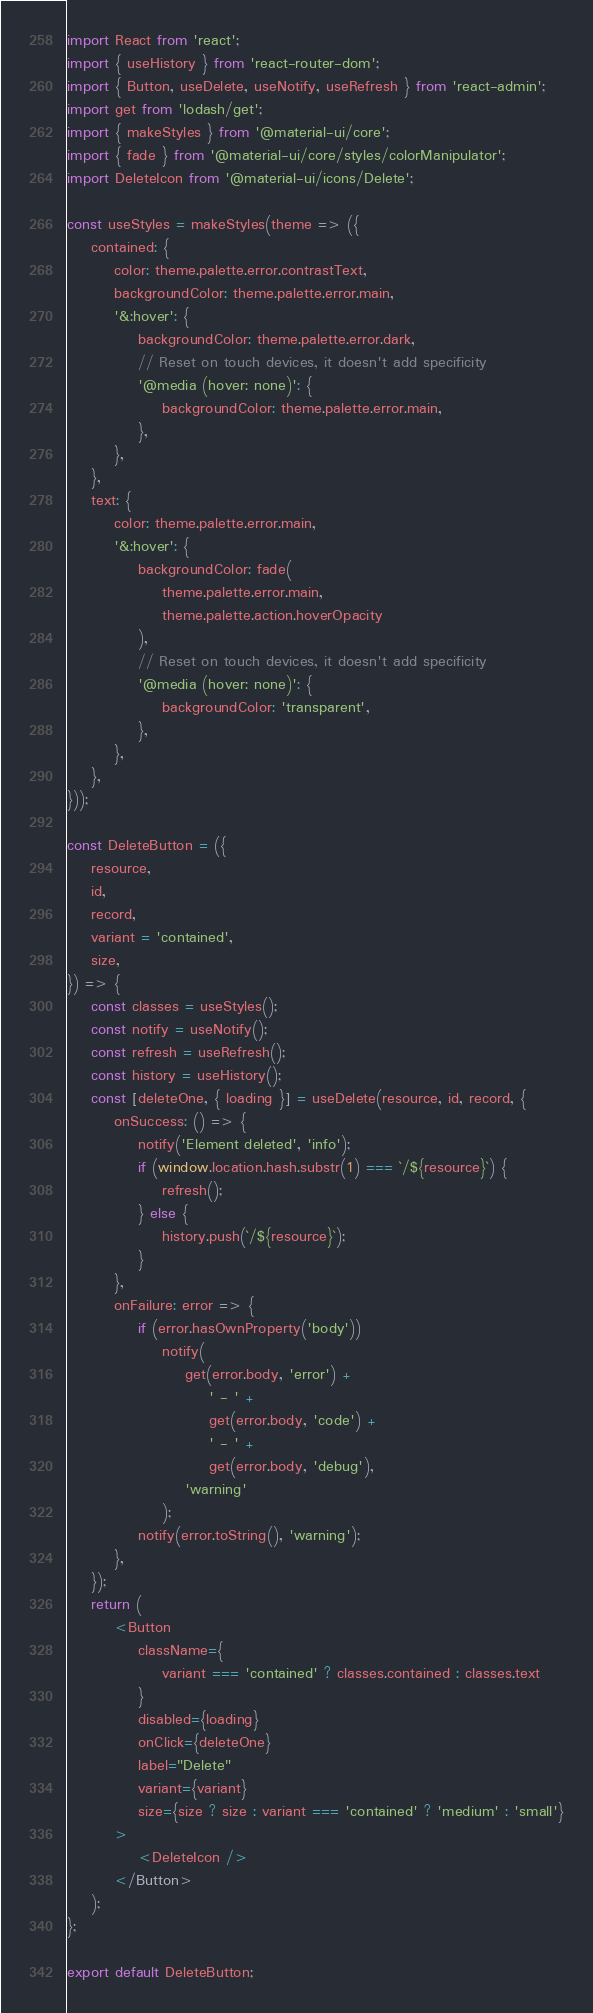<code> <loc_0><loc_0><loc_500><loc_500><_JavaScript_>import React from 'react';
import { useHistory } from 'react-router-dom';
import { Button, useDelete, useNotify, useRefresh } from 'react-admin';
import get from 'lodash/get';
import { makeStyles } from '@material-ui/core';
import { fade } from '@material-ui/core/styles/colorManipulator';
import DeleteIcon from '@material-ui/icons/Delete';

const useStyles = makeStyles(theme => ({
    contained: {
        color: theme.palette.error.contrastText,
        backgroundColor: theme.palette.error.main,
        '&:hover': {
            backgroundColor: theme.palette.error.dark,
            // Reset on touch devices, it doesn't add specificity
            '@media (hover: none)': {
                backgroundColor: theme.palette.error.main,
            },
        },
    },
    text: {
        color: theme.palette.error.main,
        '&:hover': {
            backgroundColor: fade(
                theme.palette.error.main,
                theme.palette.action.hoverOpacity
            ),
            // Reset on touch devices, it doesn't add specificity
            '@media (hover: none)': {
                backgroundColor: 'transparent',
            },
        },
    },
}));

const DeleteButton = ({
    resource,
    id,
    record,
    variant = 'contained',
    size,
}) => {
    const classes = useStyles();
    const notify = useNotify();
    const refresh = useRefresh();
    const history = useHistory();
    const [deleteOne, { loading }] = useDelete(resource, id, record, {
        onSuccess: () => {
            notify('Element deleted', 'info');
            if (window.location.hash.substr(1) === `/${resource}`) {
                refresh();
            } else {
                history.push(`/${resource}`);
            }
        },
        onFailure: error => {
            if (error.hasOwnProperty('body'))
                notify(
                    get(error.body, 'error') +
                        ' - ' +
                        get(error.body, 'code') +
                        ' - ' +
                        get(error.body, 'debug'),
                    'warning'
                );
            notify(error.toString(), 'warning');
        },
    });
    return (
        <Button
            className={
                variant === 'contained' ? classes.contained : classes.text
            }
            disabled={loading}
            onClick={deleteOne}
            label="Delete"
            variant={variant}
            size={size ? size : variant === 'contained' ? 'medium' : 'small'}
        >
            <DeleteIcon />
        </Button>
    );
};

export default DeleteButton;
</code> 